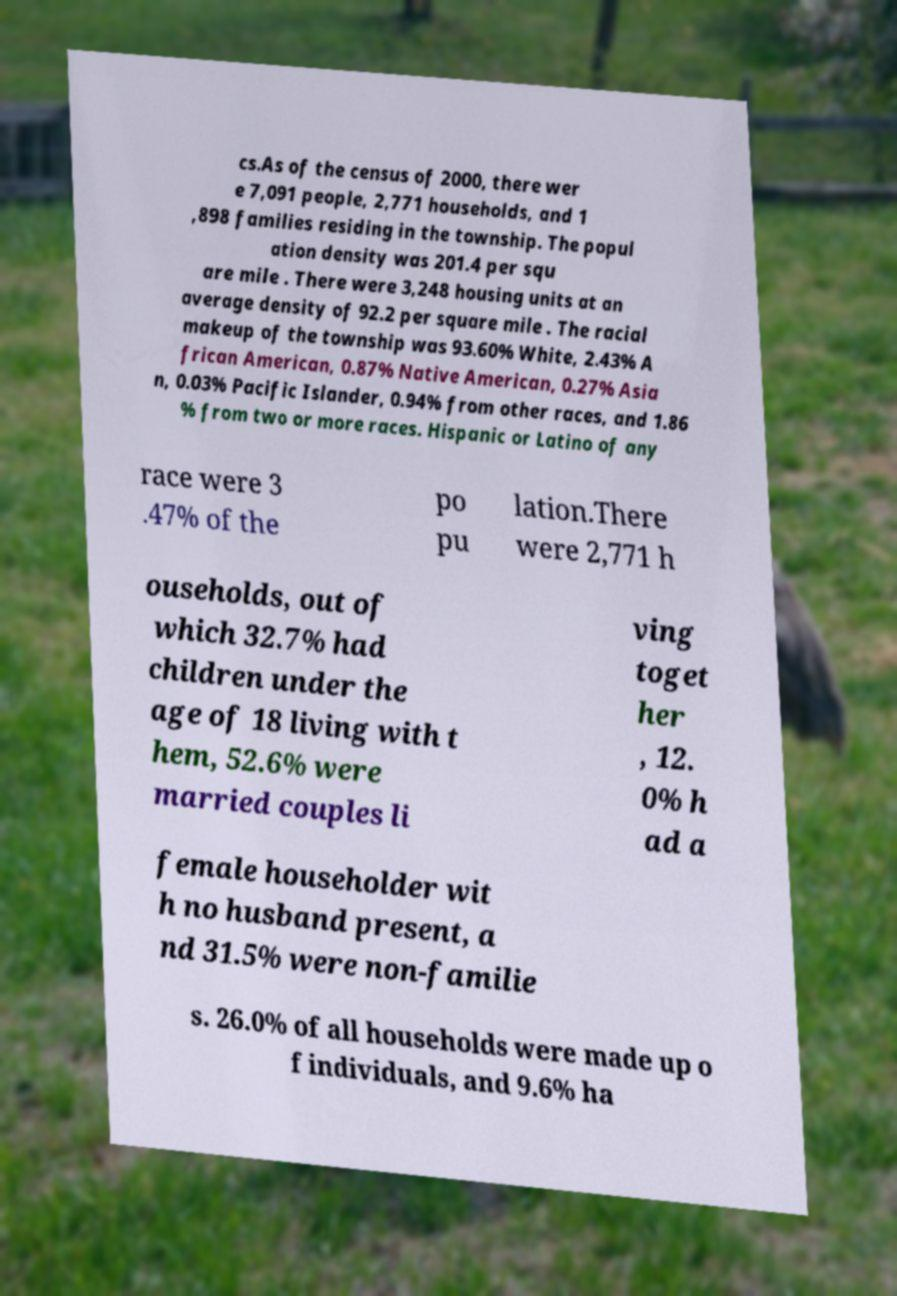There's text embedded in this image that I need extracted. Can you transcribe it verbatim? cs.As of the census of 2000, there wer e 7,091 people, 2,771 households, and 1 ,898 families residing in the township. The popul ation density was 201.4 per squ are mile . There were 3,248 housing units at an average density of 92.2 per square mile . The racial makeup of the township was 93.60% White, 2.43% A frican American, 0.87% Native American, 0.27% Asia n, 0.03% Pacific Islander, 0.94% from other races, and 1.86 % from two or more races. Hispanic or Latino of any race were 3 .47% of the po pu lation.There were 2,771 h ouseholds, out of which 32.7% had children under the age of 18 living with t hem, 52.6% were married couples li ving toget her , 12. 0% h ad a female householder wit h no husband present, a nd 31.5% were non-familie s. 26.0% of all households were made up o f individuals, and 9.6% ha 